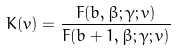Convert formula to latex. <formula><loc_0><loc_0><loc_500><loc_500>K ( v ) = \frac { F ( b , \beta ; \gamma ; v ) } { F ( b + 1 , \beta ; \gamma ; v ) }</formula> 